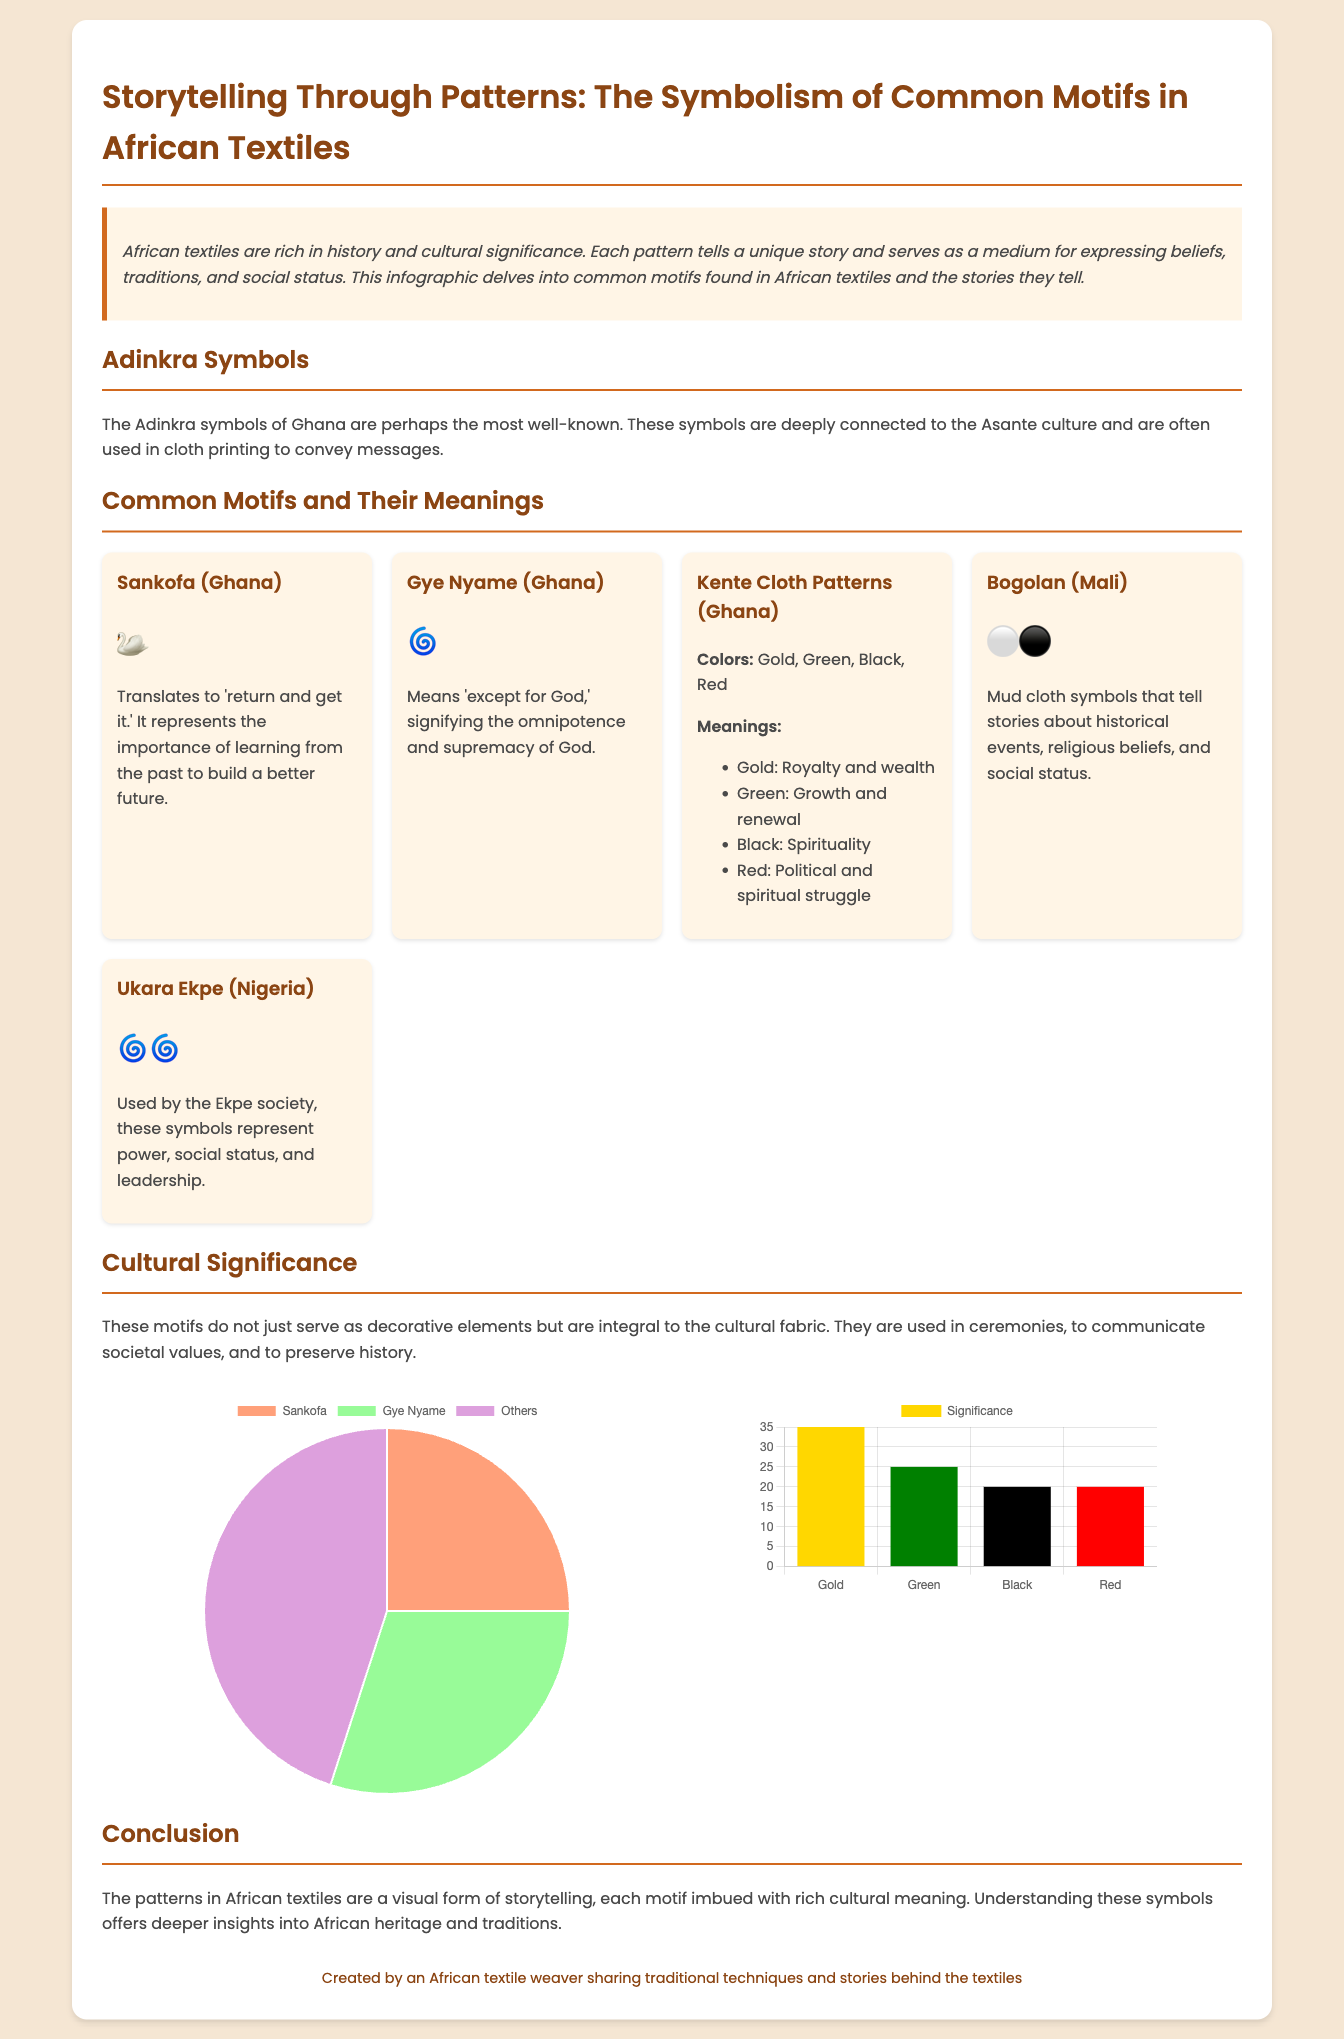what is the most well-known textile symbol from Ghana? The document states that the Adinkra symbols of Ghana are perhaps the most well-known.
Answer: Adinkra symbols what does Sankofa represent? Sankofa translates to 'return and get it' and represents the importance of learning from the past.
Answer: Learn from the past how many main colors are associated with Kente cloth? The document lists four main colors in Kente cloth patterns: Gold, Green, Black, and Red.
Answer: Four what is the significance of the color gold in Kente cloth? The document states that gold signifies royalty and wealth.
Answer: Royalty and wealth what percentage of Adinkra symbols usage does Gye Nyame represent? According to the pie chart, Gye Nyame represents 30 percent of Adinkra symbols usage.
Answer: 30 percent what are the two symbols used by the Ekpe society? The document specifies that Ukara Ekpe symbols represent power and social status.
Answer: Power, social status what does Bogolan cloth's symbols tell stories about? The document mentions that Bogolan symbols tell stories about historical events.
Answer: Historical events which chart illustrates the significance of colors in Kente cloth? The bar chart demonstrates the significance of colors in Kente cloth.
Answer: Kente color chart what does the Kente cloth's red color symbolize? The document describes that red symbolizes political and spiritual struggle.
Answer: Political and spiritual struggle 